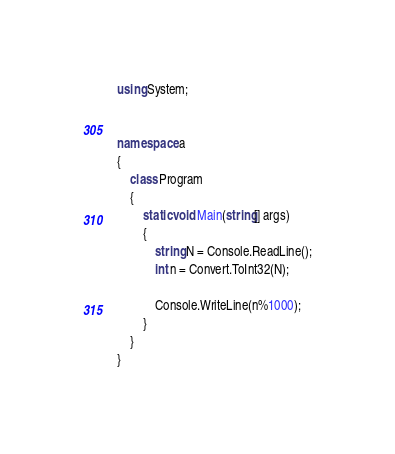Convert code to text. <code><loc_0><loc_0><loc_500><loc_500><_C#_>using System;


namespace a
{
    class Program
    {
        static void Main(string[] args)
        {
            string N = Console.ReadLine();
            int n = Convert.ToInt32(N);

            Console.WriteLine(n%1000);
        }
    }
}</code> 